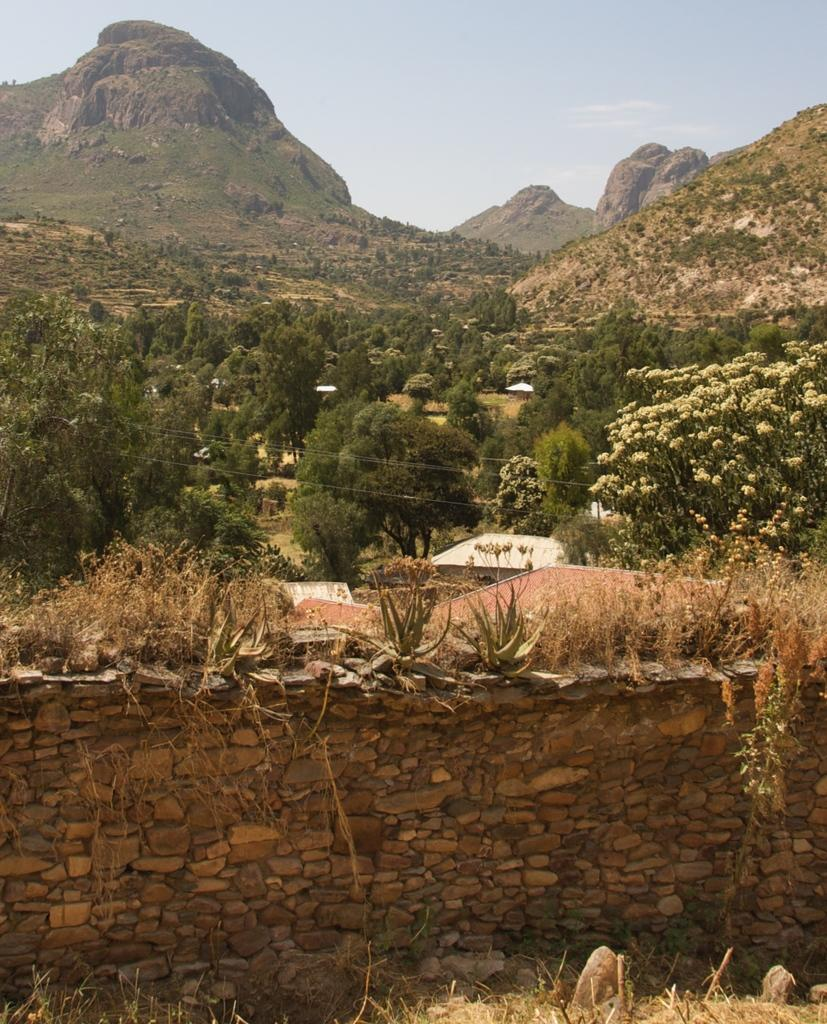What is present on the wall in the image? There are plants on the wall in the image. What can be seen in the background of the image? There are trees and a mountain in the background of the image. What is visible in the sky in the image? The sky is visible in the background of the image. What is the cause of the peace in the alley depicted in the image? There is no alley present in the image, and therefore no cause of peace can be determined. 